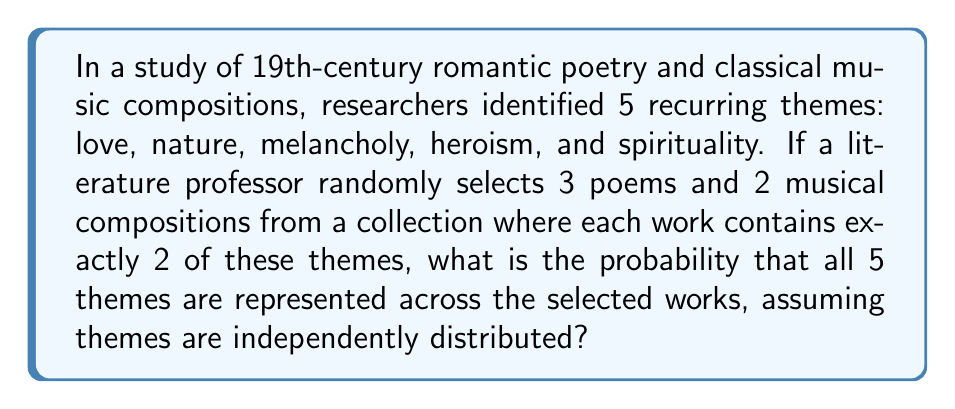Help me with this question. Let's approach this step-by-step:

1) First, we need to calculate the total number of ways to select themes for 5 works (3 poems and 2 compositions), where each work has 2 themes.

   Total selections = $\binom{5}{2}^5 = 10^5 = 100,000$

2) Now, we need to find the number of favorable outcomes (selections where all 5 themes are represented).

3) To ensure all 5 themes are represented, we can use the inclusion-exclusion principle:

   $$N = \binom{5}{5} \cdot 5^5 - \binom{5}{4} \cdot 4^5 + \binom{5}{3} \cdot 3^5 - \binom{5}{2} \cdot 2^5 + \binom{5}{1} \cdot 1^5$$

4) Let's calculate each term:
   
   $\binom{5}{5} \cdot 5^5 = 1 \cdot 3125 = 3125$
   $\binom{5}{4} \cdot 4^5 = 5 \cdot 1024 = 5120$
   $\binom{5}{3} \cdot 3^5 = 10 \cdot 243 = 2430$
   $\binom{5}{2} \cdot 2^5 = 10 \cdot 32 = 320$
   $\binom{5}{1} \cdot 1^5 = 5 \cdot 1 = 5$

5) Substituting these values:

   $N = 3125 - 5120 + 2430 - 320 + 5 = 120$

6) Therefore, the probability is:

   $$P(\text{all themes represented}) = \frac{120}{100,000} = \frac{3}{2500} = 0.0012$$
Answer: $\frac{3}{2500}$ or $0.0012$ or $0.12\%$ 